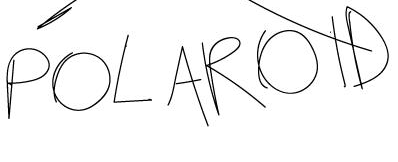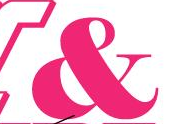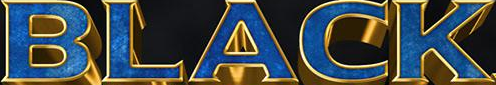Transcribe the words shown in these images in order, separated by a semicolon. POLAROID; &; BLACK 